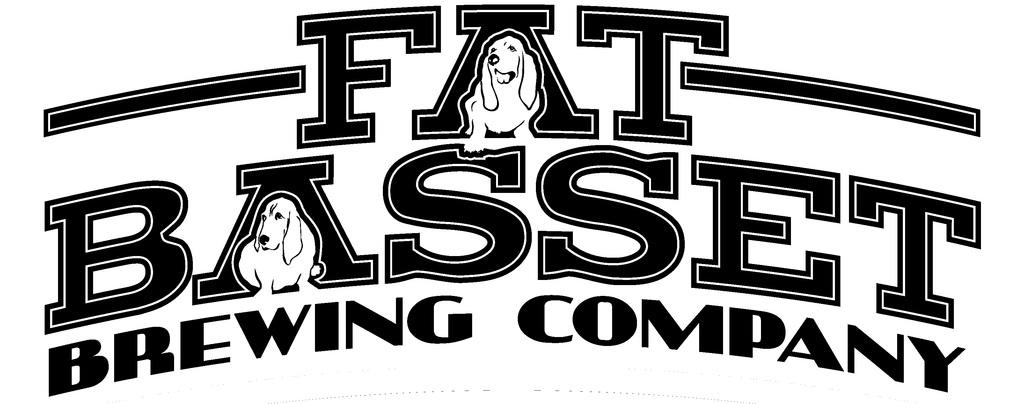What is the main feature in the center of the image? There is text in the center of the image. What type of images can be seen in the image? There are pictures of dogs in the image. What color is the background of the image? The background of the image is white. Can you tell me how many sisters are depicted in the image? There are no sisters depicted in the image; it features text and pictures of dogs. What type of insect can be seen in the image? There are no insects present in the image. 